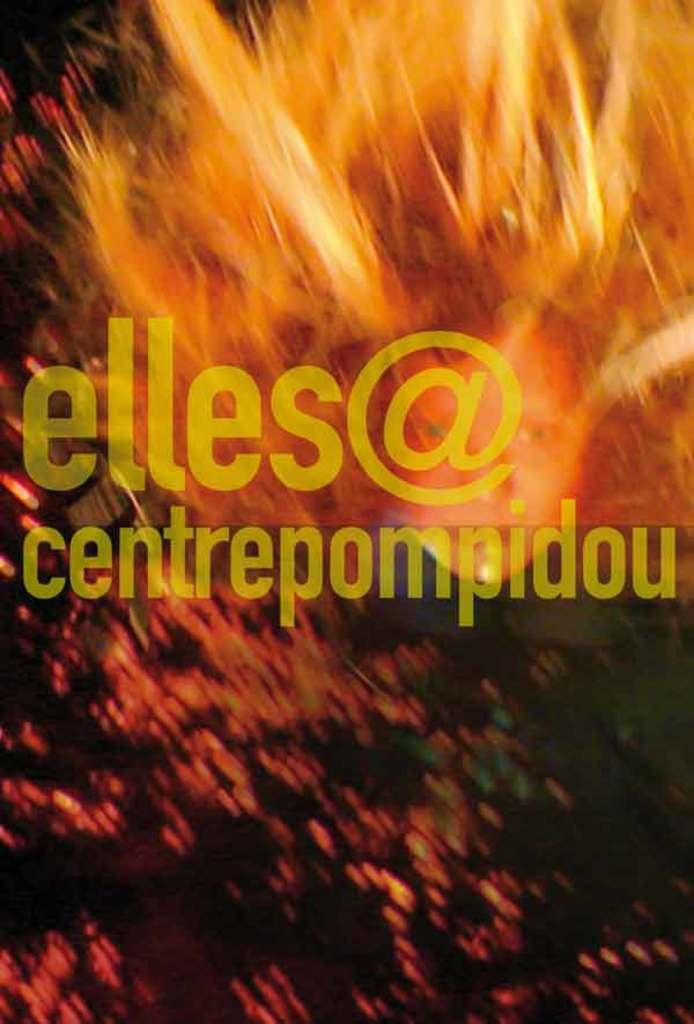<image>
Write a terse but informative summary of the picture. An abstract poster with a fiery look contains an email address for elles. 